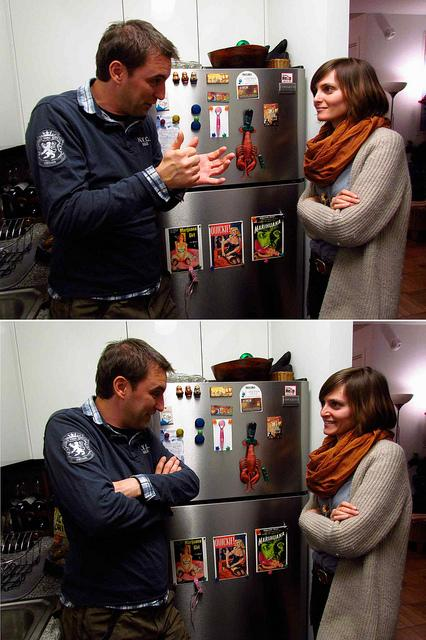How did the women feel about the man's remark? happy 